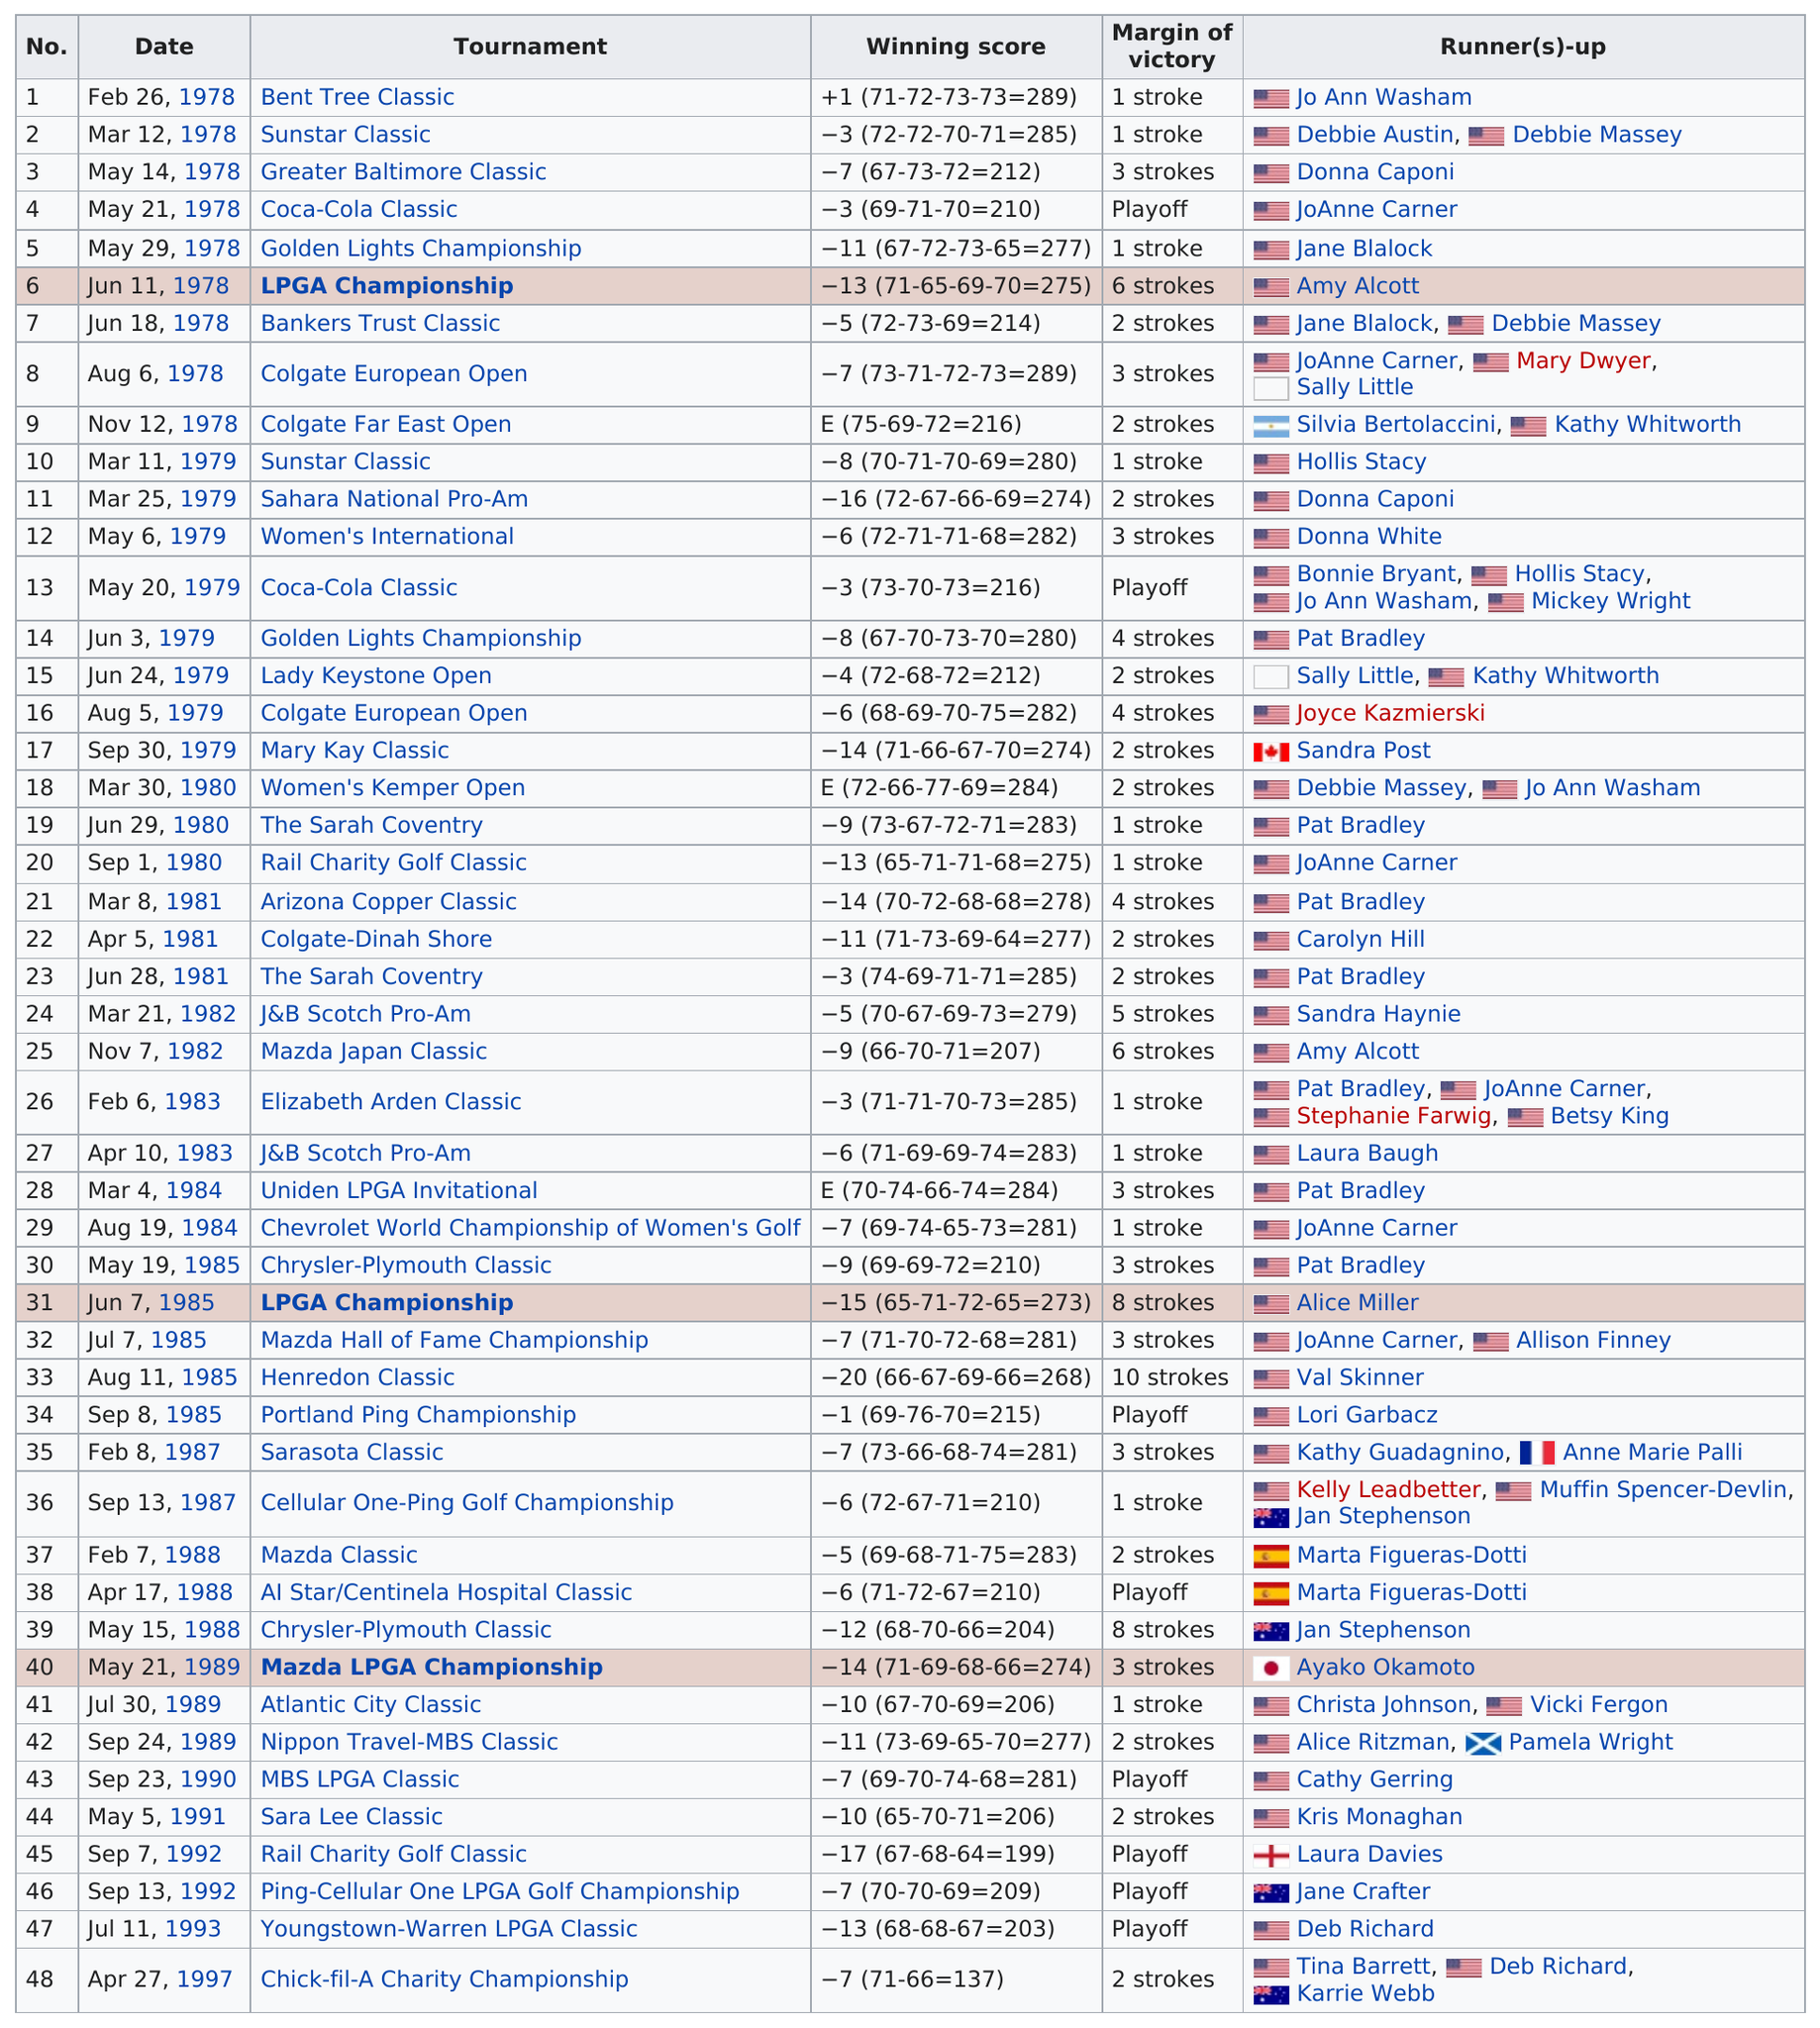List a handful of essential elements in this visual. In the Bent Tree Classic, the margin of victory was either above or below 2 strokes. If it was below 2 strokes, it was considered a narrow victory. According to the chart, there are 48 tournaments listed. Nancy Lopez won her first LPGA Tour victory at the Bent Tree Classic in 1978. The player in the table with the most runners-up finishes is JoAnne Carner. The total score for first place in the Greater Baltimore Classic is 212. 